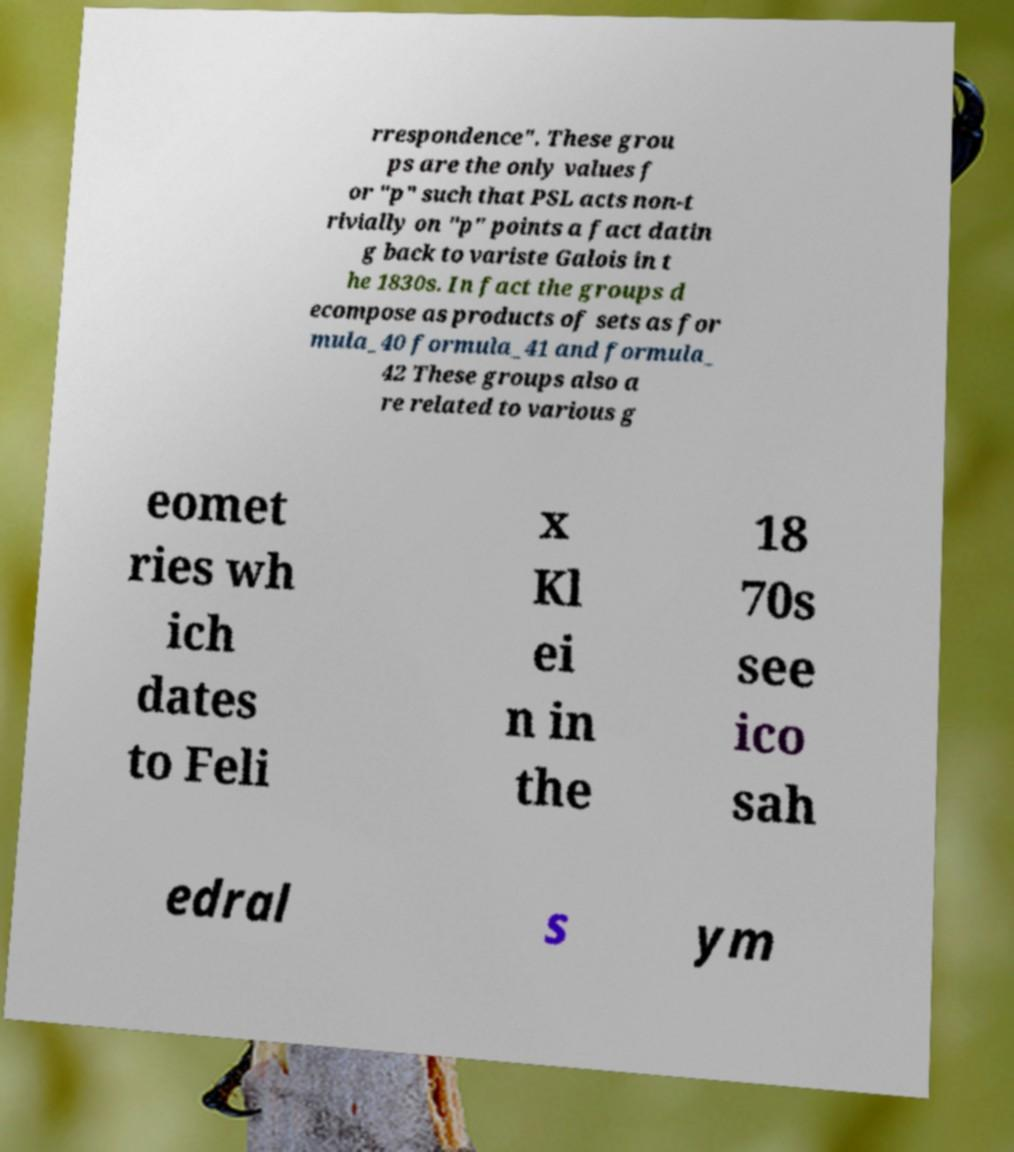Could you extract and type out the text from this image? rrespondence". These grou ps are the only values f or "p" such that PSL acts non-t rivially on "p" points a fact datin g back to variste Galois in t he 1830s. In fact the groups d ecompose as products of sets as for mula_40 formula_41 and formula_ 42 These groups also a re related to various g eomet ries wh ich dates to Feli x Kl ei n in the 18 70s see ico sah edral s ym 